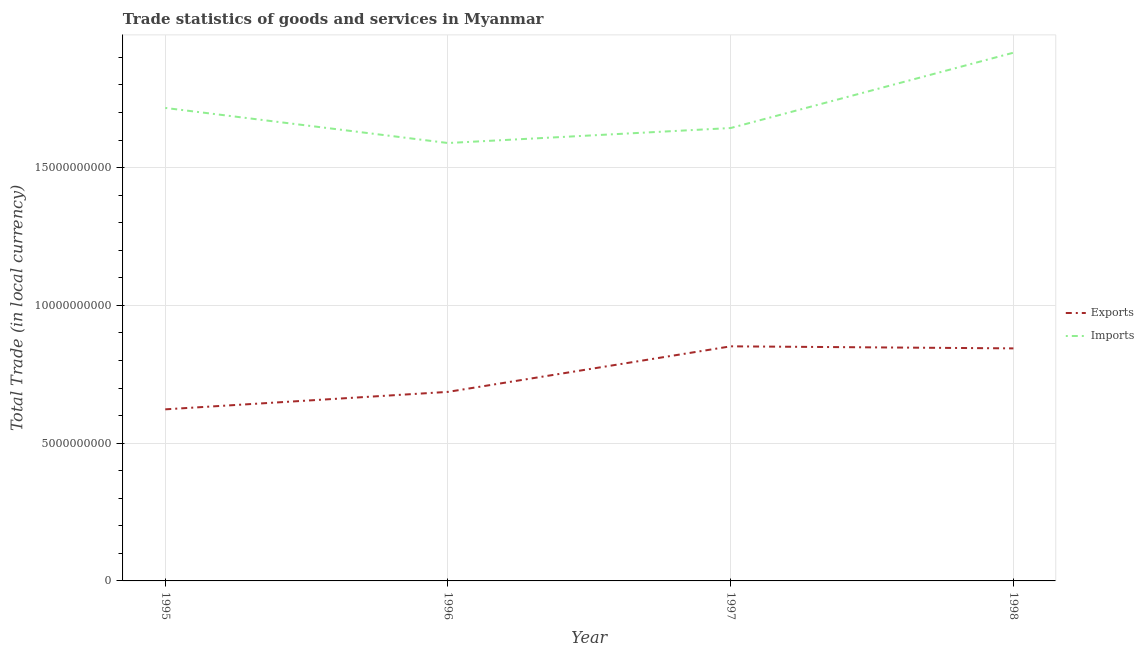Does the line corresponding to imports of goods and services intersect with the line corresponding to export of goods and services?
Make the answer very short. No. What is the imports of goods and services in 1998?
Your answer should be compact. 1.92e+1. Across all years, what is the maximum export of goods and services?
Provide a short and direct response. 8.51e+09. Across all years, what is the minimum export of goods and services?
Ensure brevity in your answer.  6.23e+09. In which year was the imports of goods and services minimum?
Give a very brief answer. 1996. What is the total imports of goods and services in the graph?
Keep it short and to the point. 6.87e+1. What is the difference between the export of goods and services in 1997 and that in 1998?
Provide a short and direct response. 7.46e+07. What is the difference between the imports of goods and services in 1997 and the export of goods and services in 1998?
Make the answer very short. 8.00e+09. What is the average export of goods and services per year?
Your answer should be compact. 7.51e+09. In the year 1995, what is the difference between the imports of goods and services and export of goods and services?
Provide a succinct answer. 1.09e+1. In how many years, is the imports of goods and services greater than 7000000000 LCU?
Your response must be concise. 4. What is the ratio of the imports of goods and services in 1995 to that in 1996?
Make the answer very short. 1.08. Is the difference between the export of goods and services in 1996 and 1997 greater than the difference between the imports of goods and services in 1996 and 1997?
Give a very brief answer. No. What is the difference between the highest and the second highest imports of goods and services?
Your answer should be very brief. 2.00e+09. What is the difference between the highest and the lowest export of goods and services?
Your response must be concise. 2.29e+09. Does the export of goods and services monotonically increase over the years?
Offer a very short reply. No. Is the imports of goods and services strictly greater than the export of goods and services over the years?
Make the answer very short. Yes. How many lines are there?
Ensure brevity in your answer.  2. What is the difference between two consecutive major ticks on the Y-axis?
Your response must be concise. 5.00e+09. Are the values on the major ticks of Y-axis written in scientific E-notation?
Offer a terse response. No. Does the graph contain any zero values?
Provide a succinct answer. No. Does the graph contain grids?
Ensure brevity in your answer.  Yes. Where does the legend appear in the graph?
Make the answer very short. Center right. How are the legend labels stacked?
Provide a succinct answer. Vertical. What is the title of the graph?
Your response must be concise. Trade statistics of goods and services in Myanmar. What is the label or title of the Y-axis?
Your answer should be very brief. Total Trade (in local currency). What is the Total Trade (in local currency) in Exports in 1995?
Make the answer very short. 6.23e+09. What is the Total Trade (in local currency) in Imports in 1995?
Ensure brevity in your answer.  1.72e+1. What is the Total Trade (in local currency) of Exports in 1996?
Your response must be concise. 6.86e+09. What is the Total Trade (in local currency) in Imports in 1996?
Provide a succinct answer. 1.59e+1. What is the Total Trade (in local currency) of Exports in 1997?
Ensure brevity in your answer.  8.51e+09. What is the Total Trade (in local currency) of Imports in 1997?
Make the answer very short. 1.64e+1. What is the Total Trade (in local currency) of Exports in 1998?
Give a very brief answer. 8.44e+09. What is the Total Trade (in local currency) in Imports in 1998?
Your answer should be compact. 1.92e+1. Across all years, what is the maximum Total Trade (in local currency) in Exports?
Provide a succinct answer. 8.51e+09. Across all years, what is the maximum Total Trade (in local currency) in Imports?
Your response must be concise. 1.92e+1. Across all years, what is the minimum Total Trade (in local currency) of Exports?
Ensure brevity in your answer.  6.23e+09. Across all years, what is the minimum Total Trade (in local currency) of Imports?
Provide a short and direct response. 1.59e+1. What is the total Total Trade (in local currency) in Exports in the graph?
Provide a short and direct response. 3.00e+1. What is the total Total Trade (in local currency) in Imports in the graph?
Your answer should be compact. 6.87e+1. What is the difference between the Total Trade (in local currency) in Exports in 1995 and that in 1996?
Offer a terse response. -6.34e+08. What is the difference between the Total Trade (in local currency) in Imports in 1995 and that in 1996?
Give a very brief answer. 1.27e+09. What is the difference between the Total Trade (in local currency) in Exports in 1995 and that in 1997?
Provide a succinct answer. -2.29e+09. What is the difference between the Total Trade (in local currency) of Imports in 1995 and that in 1997?
Your answer should be compact. 7.30e+08. What is the difference between the Total Trade (in local currency) of Exports in 1995 and that in 1998?
Give a very brief answer. -2.21e+09. What is the difference between the Total Trade (in local currency) of Imports in 1995 and that in 1998?
Ensure brevity in your answer.  -2.00e+09. What is the difference between the Total Trade (in local currency) of Exports in 1996 and that in 1997?
Your answer should be very brief. -1.65e+09. What is the difference between the Total Trade (in local currency) in Imports in 1996 and that in 1997?
Your answer should be very brief. -5.44e+08. What is the difference between the Total Trade (in local currency) in Exports in 1996 and that in 1998?
Give a very brief answer. -1.58e+09. What is the difference between the Total Trade (in local currency) in Imports in 1996 and that in 1998?
Offer a terse response. -3.28e+09. What is the difference between the Total Trade (in local currency) of Exports in 1997 and that in 1998?
Your answer should be compact. 7.46e+07. What is the difference between the Total Trade (in local currency) in Imports in 1997 and that in 1998?
Provide a short and direct response. -2.73e+09. What is the difference between the Total Trade (in local currency) in Exports in 1995 and the Total Trade (in local currency) in Imports in 1996?
Ensure brevity in your answer.  -9.66e+09. What is the difference between the Total Trade (in local currency) in Exports in 1995 and the Total Trade (in local currency) in Imports in 1997?
Offer a terse response. -1.02e+1. What is the difference between the Total Trade (in local currency) in Exports in 1995 and the Total Trade (in local currency) in Imports in 1998?
Provide a succinct answer. -1.29e+1. What is the difference between the Total Trade (in local currency) of Exports in 1996 and the Total Trade (in local currency) of Imports in 1997?
Make the answer very short. -9.58e+09. What is the difference between the Total Trade (in local currency) of Exports in 1996 and the Total Trade (in local currency) of Imports in 1998?
Keep it short and to the point. -1.23e+1. What is the difference between the Total Trade (in local currency) in Exports in 1997 and the Total Trade (in local currency) in Imports in 1998?
Offer a terse response. -1.07e+1. What is the average Total Trade (in local currency) in Exports per year?
Your answer should be compact. 7.51e+09. What is the average Total Trade (in local currency) of Imports per year?
Give a very brief answer. 1.72e+1. In the year 1995, what is the difference between the Total Trade (in local currency) in Exports and Total Trade (in local currency) in Imports?
Ensure brevity in your answer.  -1.09e+1. In the year 1996, what is the difference between the Total Trade (in local currency) of Exports and Total Trade (in local currency) of Imports?
Give a very brief answer. -9.03e+09. In the year 1997, what is the difference between the Total Trade (in local currency) of Exports and Total Trade (in local currency) of Imports?
Your answer should be very brief. -7.92e+09. In the year 1998, what is the difference between the Total Trade (in local currency) of Exports and Total Trade (in local currency) of Imports?
Your answer should be very brief. -1.07e+1. What is the ratio of the Total Trade (in local currency) of Exports in 1995 to that in 1996?
Give a very brief answer. 0.91. What is the ratio of the Total Trade (in local currency) of Imports in 1995 to that in 1996?
Ensure brevity in your answer.  1.08. What is the ratio of the Total Trade (in local currency) in Exports in 1995 to that in 1997?
Keep it short and to the point. 0.73. What is the ratio of the Total Trade (in local currency) in Imports in 1995 to that in 1997?
Offer a very short reply. 1.04. What is the ratio of the Total Trade (in local currency) in Exports in 1995 to that in 1998?
Provide a short and direct response. 0.74. What is the ratio of the Total Trade (in local currency) of Imports in 1995 to that in 1998?
Give a very brief answer. 0.9. What is the ratio of the Total Trade (in local currency) in Exports in 1996 to that in 1997?
Offer a very short reply. 0.81. What is the ratio of the Total Trade (in local currency) in Imports in 1996 to that in 1997?
Give a very brief answer. 0.97. What is the ratio of the Total Trade (in local currency) in Exports in 1996 to that in 1998?
Offer a terse response. 0.81. What is the ratio of the Total Trade (in local currency) of Imports in 1996 to that in 1998?
Keep it short and to the point. 0.83. What is the ratio of the Total Trade (in local currency) in Exports in 1997 to that in 1998?
Your answer should be very brief. 1.01. What is the ratio of the Total Trade (in local currency) of Imports in 1997 to that in 1998?
Your response must be concise. 0.86. What is the difference between the highest and the second highest Total Trade (in local currency) in Exports?
Ensure brevity in your answer.  7.46e+07. What is the difference between the highest and the second highest Total Trade (in local currency) in Imports?
Your answer should be compact. 2.00e+09. What is the difference between the highest and the lowest Total Trade (in local currency) of Exports?
Make the answer very short. 2.29e+09. What is the difference between the highest and the lowest Total Trade (in local currency) of Imports?
Offer a terse response. 3.28e+09. 